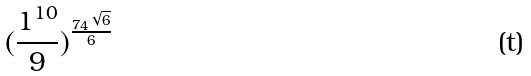<formula> <loc_0><loc_0><loc_500><loc_500>( \frac { 1 ^ { 1 0 } } { 9 } ) ^ { \frac { 7 4 ^ { \sqrt { 6 } } } { 6 } }</formula> 